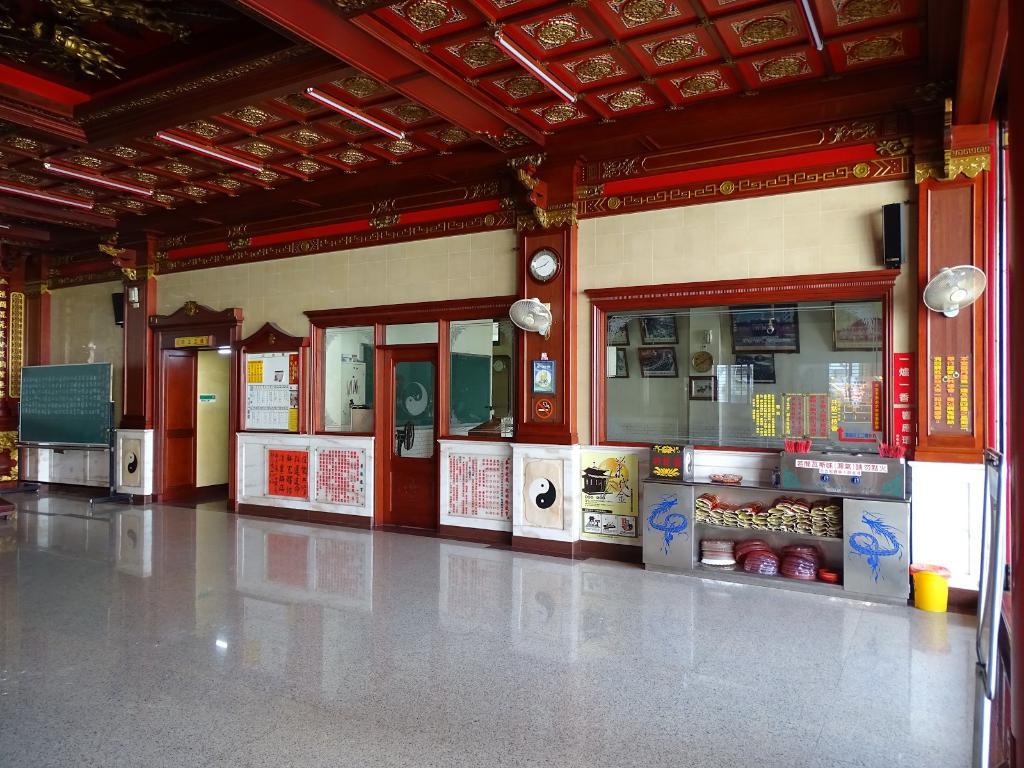Is this a cafeteria?
Keep it short and to the point. No. 